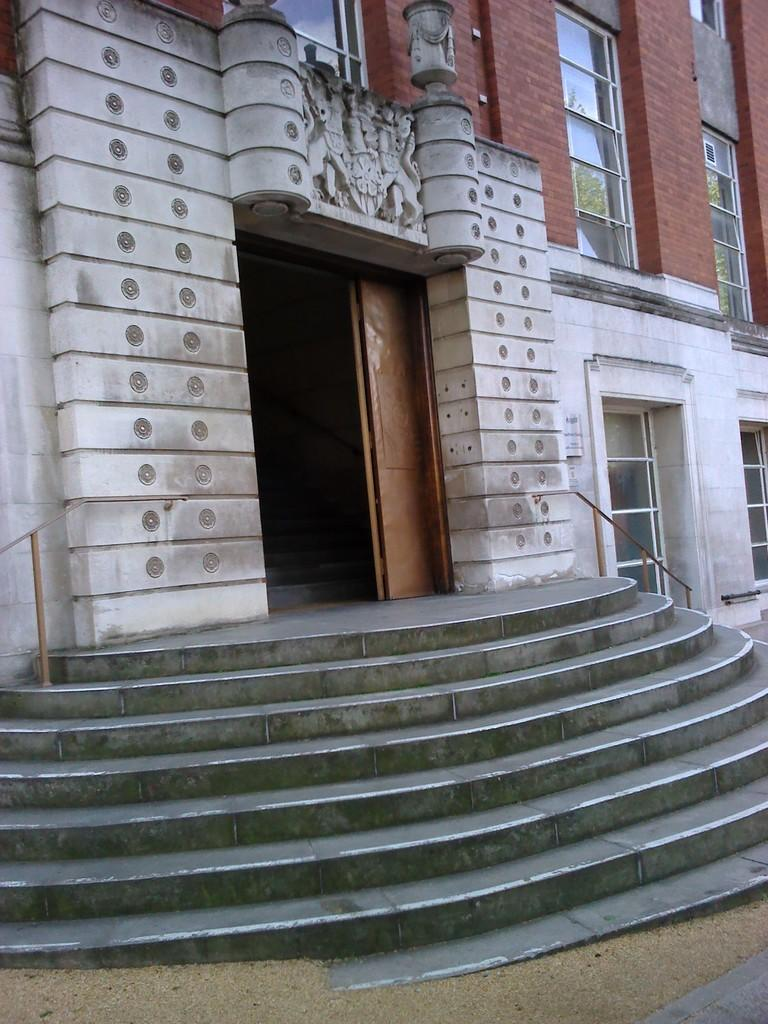What type of structure is visible in the image? There is a building in the image. What features can be seen on the building? The building has windows, a door, and stairs. Are there any decorative elements on the building? Yes, there are carvings on the wall of the building. What is the bottom portion of the image made of? The bottom portion of the image contains sand. How many tomatoes are growing on the building in the image? There are no tomatoes present in the image; the image features a building with carvings on the wall and sand at the bottom. 